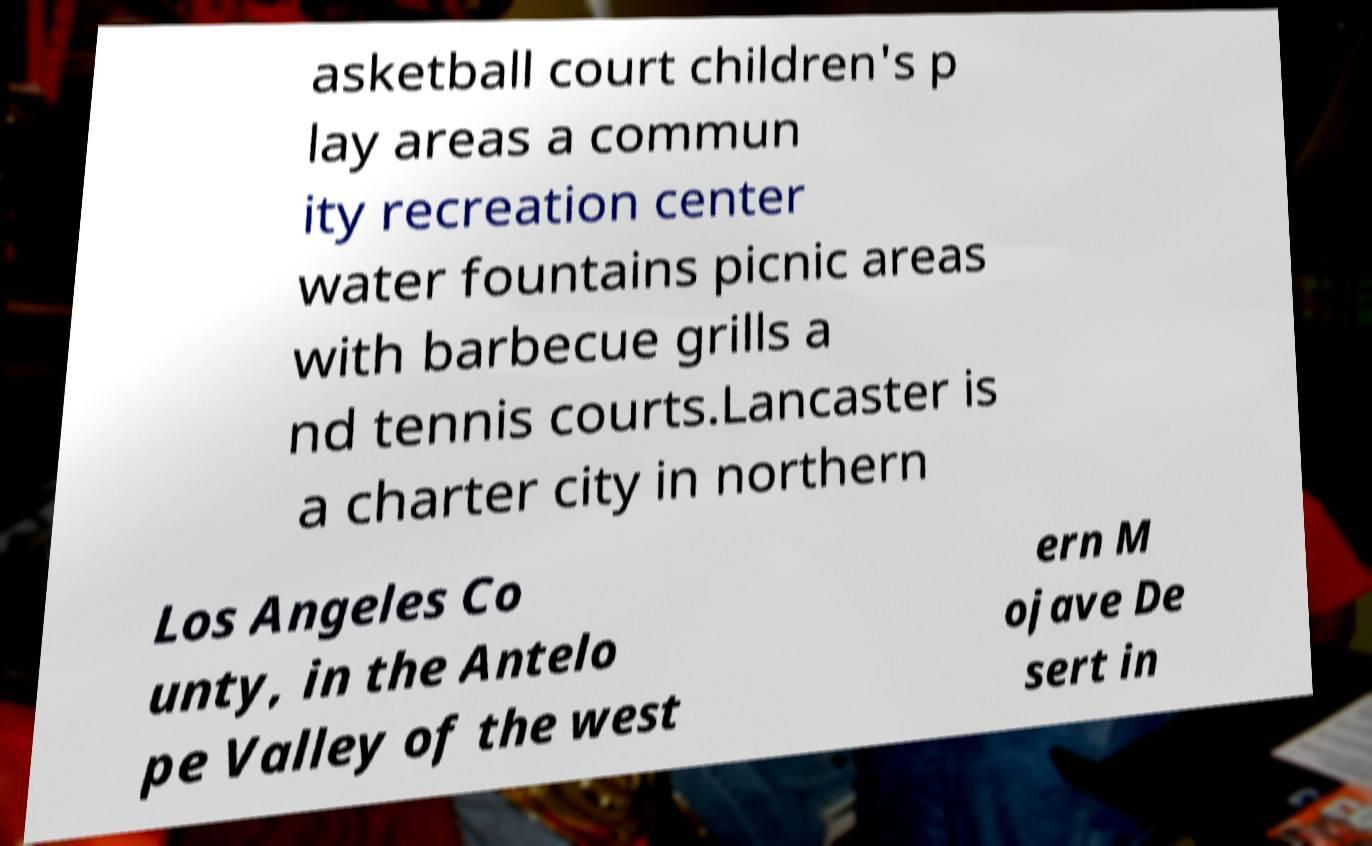Can you read and provide the text displayed in the image?This photo seems to have some interesting text. Can you extract and type it out for me? asketball court children's p lay areas a commun ity recreation center water fountains picnic areas with barbecue grills a nd tennis courts.Lancaster is a charter city in northern Los Angeles Co unty, in the Antelo pe Valley of the west ern M ojave De sert in 